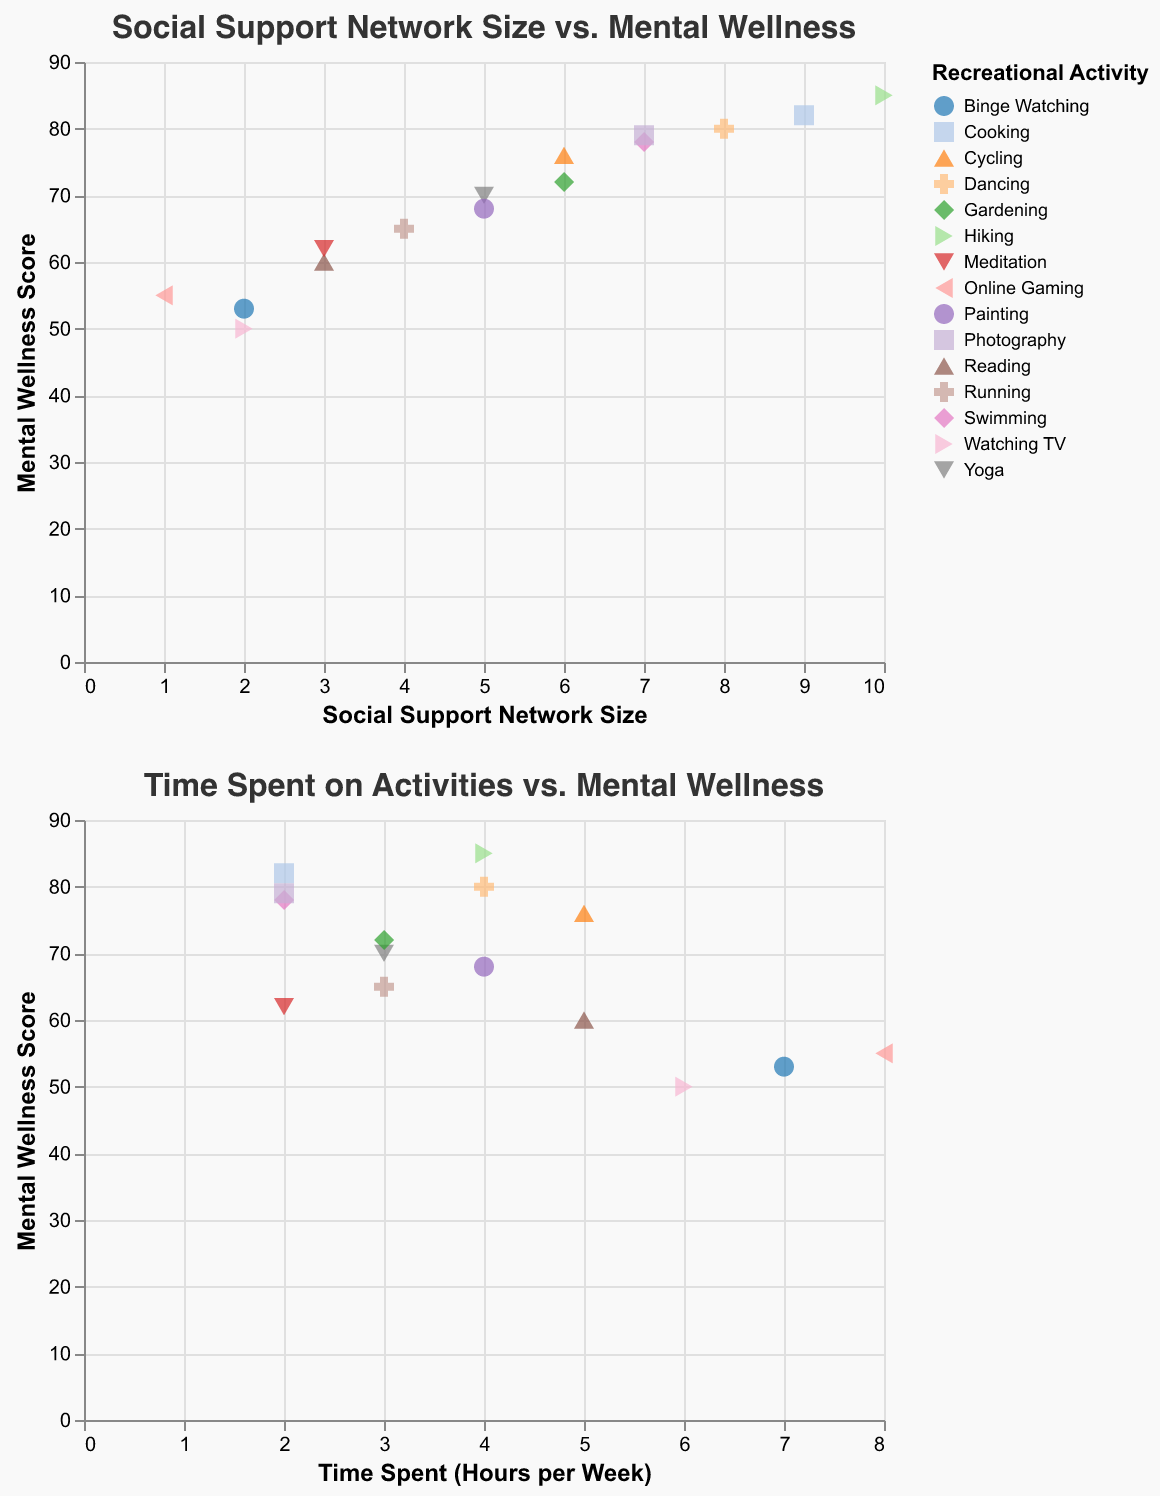How many distinct recreational activities are shown in the figure? By counting the different activities represented by different colors and shapes in the legend, you can determine there are 15 distinct recreational activities.
Answer: 15 Which activity shows the highest mental wellness score and what is the score? By examining the scatter plot, identify the point with the highest y-axis value and check the corresponding activity in the legend. The highest mental wellness score is 85, associated with Hiking.
Answer: Hiking, 85 How is the number of hours spent on recreational activities related to mental wellness scores in general? By observing the scatter plot where the x-axis represents hours spent and the y-axis represents mental wellness scores, a general pattern can be noted: higher mental wellness scores seem to be associated with moderate time spent on activities, around 2-5 hours per week, with some outliers.
Answer: Generally, moderate time spent (2-5 hours) relates to higher mental wellness Which recreational activity, Yoga or Binge Watching, is associated with a larger social support network size? Locate the points corresponding to Yoga and Binge Watching on the scatter plot and compare their x-axis values (Social Support Network Size). Yoga has a network size of 5, which is larger than Binge Watching's network size of 2.
Answer: Yoga What is the average mental wellness score for activities where participants have a social support network size of 7? Identify all points on the scatter plot where the x-axis (Social Support Network Size) is 7. The activities and their mental wellness scores are Swimming (78) and Photography (79). Calculate the average: (78 + 79) / 2 = 78.5.
Answer: 78.5 Which activity has the lowest mental wellness score, and how many hours per week is spent on it? Locate the point with the lowest y-axis value (Mental Wellness Score) on the scatter plot, which is Watching TV (score of 50). Check the tooltip or figure details for the corresponding hours, which is 6 hours per week.
Answer: Watching TV, 6 hours Do activities with higher social support network sizes generally correlate with higher mental wellness scores? Observe the general trend in the first scatter plot: points with larger x-axis values (Social Support Network Size) tend to have higher y-axis values (Mental Wellness Scores), indicating a positive correlation.
Answer: Yes Which activity is associated with an 8-hour-per-week time spent and how does its mental wellness score compare to the overall range? Locate the point at the far right of the second scatter plot where x=8 (hours per week spent). The activity is Online Gaming with a mental wellness score of 55. Comparing it to the overall range (50 to 85), it's on the lower side.
Answer: Online Gaming, relatively low Are there more activities above or below an average mental wellness score of 70? Count the data points above and below the y-axis value of 70. There are 8 points above 70 and 7 below.
Answer: More activities above What's the median social support network size for all activities? List out all social support network sizes: 1, 2, 2, 3, 3, 4, 5, 5, 6, 6, 7, 7, 8, 9, 10. Since there are 15 data points, the median is the 8th value when sorted, which is 5.
Answer: 5 